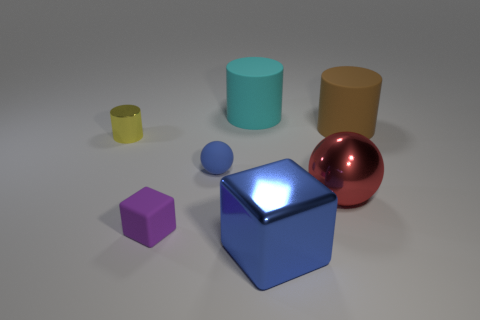There is a sphere that is on the left side of the cyan matte object; does it have the same size as the purple matte block?
Offer a very short reply. Yes. What is the size of the shiny thing that is to the left of the big red shiny ball and on the right side of the purple matte thing?
Ensure brevity in your answer.  Large. How many other things are made of the same material as the small sphere?
Keep it short and to the point. 3. How big is the cylinder that is in front of the large brown cylinder?
Provide a short and direct response. Small. Do the big cube and the tiny ball have the same color?
Offer a terse response. Yes. How many large things are balls or brown rubber cylinders?
Provide a succinct answer. 2. Are there any other things that are the same color as the shiny cube?
Make the answer very short. Yes. There is a purple matte thing; are there any metal things to the right of it?
Provide a succinct answer. Yes. What is the size of the rubber object behind the cylinder that is on the right side of the cyan thing?
Offer a very short reply. Large. Are there the same number of big objects that are behind the blue matte object and cyan cylinders in front of the big cyan object?
Ensure brevity in your answer.  No. 